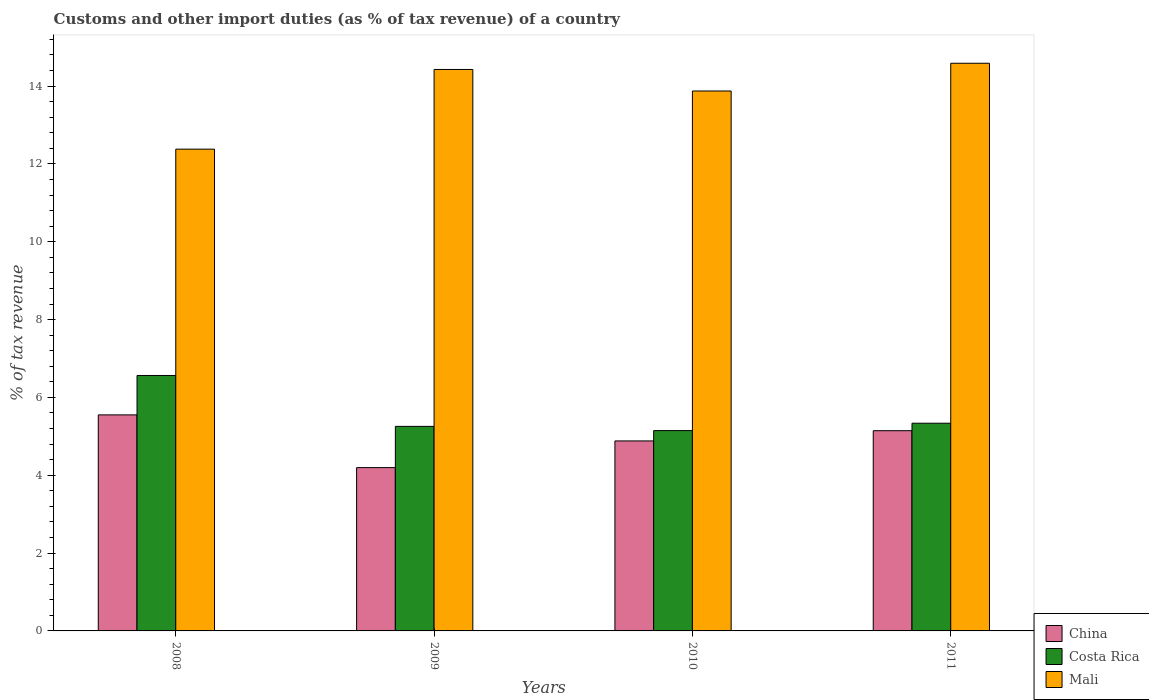How many different coloured bars are there?
Provide a short and direct response. 3. Are the number of bars per tick equal to the number of legend labels?
Offer a very short reply. Yes. Are the number of bars on each tick of the X-axis equal?
Your answer should be very brief. Yes. How many bars are there on the 4th tick from the right?
Give a very brief answer. 3. In how many cases, is the number of bars for a given year not equal to the number of legend labels?
Offer a terse response. 0. What is the percentage of tax revenue from customs in Costa Rica in 2009?
Your response must be concise. 5.26. Across all years, what is the maximum percentage of tax revenue from customs in Mali?
Provide a succinct answer. 14.59. Across all years, what is the minimum percentage of tax revenue from customs in China?
Make the answer very short. 4.2. In which year was the percentage of tax revenue from customs in Mali maximum?
Ensure brevity in your answer.  2011. What is the total percentage of tax revenue from customs in Mali in the graph?
Provide a succinct answer. 55.26. What is the difference between the percentage of tax revenue from customs in China in 2008 and that in 2009?
Provide a succinct answer. 1.36. What is the difference between the percentage of tax revenue from customs in Costa Rica in 2011 and the percentage of tax revenue from customs in Mali in 2009?
Provide a short and direct response. -9.09. What is the average percentage of tax revenue from customs in Mali per year?
Make the answer very short. 13.82. In the year 2008, what is the difference between the percentage of tax revenue from customs in Costa Rica and percentage of tax revenue from customs in China?
Make the answer very short. 1.01. In how many years, is the percentage of tax revenue from customs in Costa Rica greater than 8.4 %?
Keep it short and to the point. 0. What is the ratio of the percentage of tax revenue from customs in Mali in 2010 to that in 2011?
Provide a short and direct response. 0.95. Is the percentage of tax revenue from customs in China in 2009 less than that in 2011?
Offer a terse response. Yes. What is the difference between the highest and the second highest percentage of tax revenue from customs in Costa Rica?
Keep it short and to the point. 1.23. What is the difference between the highest and the lowest percentage of tax revenue from customs in China?
Ensure brevity in your answer.  1.36. In how many years, is the percentage of tax revenue from customs in Mali greater than the average percentage of tax revenue from customs in Mali taken over all years?
Make the answer very short. 3. Is the sum of the percentage of tax revenue from customs in Costa Rica in 2008 and 2010 greater than the maximum percentage of tax revenue from customs in Mali across all years?
Your answer should be very brief. No. What does the 3rd bar from the left in 2011 represents?
Provide a short and direct response. Mali. What does the 1st bar from the right in 2009 represents?
Offer a terse response. Mali. Is it the case that in every year, the sum of the percentage of tax revenue from customs in Mali and percentage of tax revenue from customs in Costa Rica is greater than the percentage of tax revenue from customs in China?
Offer a very short reply. Yes. Are all the bars in the graph horizontal?
Ensure brevity in your answer.  No. How many years are there in the graph?
Your answer should be very brief. 4. How are the legend labels stacked?
Your response must be concise. Vertical. What is the title of the graph?
Give a very brief answer. Customs and other import duties (as % of tax revenue) of a country. Does "United Arab Emirates" appear as one of the legend labels in the graph?
Make the answer very short. No. What is the label or title of the X-axis?
Give a very brief answer. Years. What is the label or title of the Y-axis?
Ensure brevity in your answer.  % of tax revenue. What is the % of tax revenue in China in 2008?
Your answer should be compact. 5.55. What is the % of tax revenue of Costa Rica in 2008?
Your answer should be very brief. 6.56. What is the % of tax revenue in Mali in 2008?
Offer a terse response. 12.38. What is the % of tax revenue in China in 2009?
Make the answer very short. 4.2. What is the % of tax revenue in Costa Rica in 2009?
Your answer should be compact. 5.26. What is the % of tax revenue of Mali in 2009?
Offer a very short reply. 14.43. What is the % of tax revenue of China in 2010?
Keep it short and to the point. 4.88. What is the % of tax revenue of Costa Rica in 2010?
Offer a very short reply. 5.15. What is the % of tax revenue in Mali in 2010?
Your answer should be compact. 13.87. What is the % of tax revenue in China in 2011?
Ensure brevity in your answer.  5.14. What is the % of tax revenue of Costa Rica in 2011?
Your response must be concise. 5.34. What is the % of tax revenue of Mali in 2011?
Offer a very short reply. 14.59. Across all years, what is the maximum % of tax revenue in China?
Provide a succinct answer. 5.55. Across all years, what is the maximum % of tax revenue of Costa Rica?
Offer a terse response. 6.56. Across all years, what is the maximum % of tax revenue in Mali?
Ensure brevity in your answer.  14.59. Across all years, what is the minimum % of tax revenue in China?
Your answer should be compact. 4.2. Across all years, what is the minimum % of tax revenue in Costa Rica?
Make the answer very short. 5.15. Across all years, what is the minimum % of tax revenue of Mali?
Provide a short and direct response. 12.38. What is the total % of tax revenue of China in the graph?
Make the answer very short. 19.77. What is the total % of tax revenue of Costa Rica in the graph?
Give a very brief answer. 22.3. What is the total % of tax revenue in Mali in the graph?
Give a very brief answer. 55.26. What is the difference between the % of tax revenue of China in 2008 and that in 2009?
Your response must be concise. 1.36. What is the difference between the % of tax revenue in Costa Rica in 2008 and that in 2009?
Make the answer very short. 1.31. What is the difference between the % of tax revenue of Mali in 2008 and that in 2009?
Provide a succinct answer. -2.05. What is the difference between the % of tax revenue of China in 2008 and that in 2010?
Offer a very short reply. 0.67. What is the difference between the % of tax revenue of Costa Rica in 2008 and that in 2010?
Ensure brevity in your answer.  1.42. What is the difference between the % of tax revenue of Mali in 2008 and that in 2010?
Ensure brevity in your answer.  -1.49. What is the difference between the % of tax revenue of China in 2008 and that in 2011?
Give a very brief answer. 0.41. What is the difference between the % of tax revenue of Costa Rica in 2008 and that in 2011?
Your answer should be very brief. 1.23. What is the difference between the % of tax revenue in Mali in 2008 and that in 2011?
Your answer should be compact. -2.21. What is the difference between the % of tax revenue of China in 2009 and that in 2010?
Ensure brevity in your answer.  -0.69. What is the difference between the % of tax revenue in Costa Rica in 2009 and that in 2010?
Provide a succinct answer. 0.11. What is the difference between the % of tax revenue of Mali in 2009 and that in 2010?
Your answer should be very brief. 0.55. What is the difference between the % of tax revenue of China in 2009 and that in 2011?
Your response must be concise. -0.95. What is the difference between the % of tax revenue in Costa Rica in 2009 and that in 2011?
Offer a very short reply. -0.08. What is the difference between the % of tax revenue of Mali in 2009 and that in 2011?
Provide a short and direct response. -0.16. What is the difference between the % of tax revenue in China in 2010 and that in 2011?
Your answer should be compact. -0.26. What is the difference between the % of tax revenue in Costa Rica in 2010 and that in 2011?
Your response must be concise. -0.19. What is the difference between the % of tax revenue of Mali in 2010 and that in 2011?
Make the answer very short. -0.71. What is the difference between the % of tax revenue in China in 2008 and the % of tax revenue in Costa Rica in 2009?
Ensure brevity in your answer.  0.3. What is the difference between the % of tax revenue in China in 2008 and the % of tax revenue in Mali in 2009?
Make the answer very short. -8.88. What is the difference between the % of tax revenue of Costa Rica in 2008 and the % of tax revenue of Mali in 2009?
Make the answer very short. -7.86. What is the difference between the % of tax revenue in China in 2008 and the % of tax revenue in Costa Rica in 2010?
Keep it short and to the point. 0.4. What is the difference between the % of tax revenue in China in 2008 and the % of tax revenue in Mali in 2010?
Offer a terse response. -8.32. What is the difference between the % of tax revenue of Costa Rica in 2008 and the % of tax revenue of Mali in 2010?
Provide a short and direct response. -7.31. What is the difference between the % of tax revenue in China in 2008 and the % of tax revenue in Costa Rica in 2011?
Provide a short and direct response. 0.21. What is the difference between the % of tax revenue of China in 2008 and the % of tax revenue of Mali in 2011?
Your answer should be compact. -9.03. What is the difference between the % of tax revenue of Costa Rica in 2008 and the % of tax revenue of Mali in 2011?
Offer a very short reply. -8.02. What is the difference between the % of tax revenue in China in 2009 and the % of tax revenue in Costa Rica in 2010?
Make the answer very short. -0.95. What is the difference between the % of tax revenue of China in 2009 and the % of tax revenue of Mali in 2010?
Make the answer very short. -9.68. What is the difference between the % of tax revenue of Costa Rica in 2009 and the % of tax revenue of Mali in 2010?
Give a very brief answer. -8.62. What is the difference between the % of tax revenue in China in 2009 and the % of tax revenue in Costa Rica in 2011?
Your answer should be very brief. -1.14. What is the difference between the % of tax revenue of China in 2009 and the % of tax revenue of Mali in 2011?
Give a very brief answer. -10.39. What is the difference between the % of tax revenue of Costa Rica in 2009 and the % of tax revenue of Mali in 2011?
Offer a very short reply. -9.33. What is the difference between the % of tax revenue in China in 2010 and the % of tax revenue in Costa Rica in 2011?
Your response must be concise. -0.45. What is the difference between the % of tax revenue in China in 2010 and the % of tax revenue in Mali in 2011?
Make the answer very short. -9.7. What is the difference between the % of tax revenue in Costa Rica in 2010 and the % of tax revenue in Mali in 2011?
Give a very brief answer. -9.44. What is the average % of tax revenue in China per year?
Offer a very short reply. 4.94. What is the average % of tax revenue of Costa Rica per year?
Give a very brief answer. 5.58. What is the average % of tax revenue in Mali per year?
Your answer should be very brief. 13.82. In the year 2008, what is the difference between the % of tax revenue in China and % of tax revenue in Costa Rica?
Make the answer very short. -1.01. In the year 2008, what is the difference between the % of tax revenue of China and % of tax revenue of Mali?
Provide a succinct answer. -6.83. In the year 2008, what is the difference between the % of tax revenue of Costa Rica and % of tax revenue of Mali?
Your answer should be very brief. -5.82. In the year 2009, what is the difference between the % of tax revenue in China and % of tax revenue in Costa Rica?
Keep it short and to the point. -1.06. In the year 2009, what is the difference between the % of tax revenue of China and % of tax revenue of Mali?
Your answer should be very brief. -10.23. In the year 2009, what is the difference between the % of tax revenue in Costa Rica and % of tax revenue in Mali?
Ensure brevity in your answer.  -9.17. In the year 2010, what is the difference between the % of tax revenue in China and % of tax revenue in Costa Rica?
Your response must be concise. -0.27. In the year 2010, what is the difference between the % of tax revenue in China and % of tax revenue in Mali?
Keep it short and to the point. -8.99. In the year 2010, what is the difference between the % of tax revenue of Costa Rica and % of tax revenue of Mali?
Ensure brevity in your answer.  -8.73. In the year 2011, what is the difference between the % of tax revenue in China and % of tax revenue in Costa Rica?
Give a very brief answer. -0.19. In the year 2011, what is the difference between the % of tax revenue of China and % of tax revenue of Mali?
Give a very brief answer. -9.44. In the year 2011, what is the difference between the % of tax revenue of Costa Rica and % of tax revenue of Mali?
Keep it short and to the point. -9.25. What is the ratio of the % of tax revenue in China in 2008 to that in 2009?
Your answer should be very brief. 1.32. What is the ratio of the % of tax revenue of Costa Rica in 2008 to that in 2009?
Your response must be concise. 1.25. What is the ratio of the % of tax revenue in Mali in 2008 to that in 2009?
Offer a terse response. 0.86. What is the ratio of the % of tax revenue in China in 2008 to that in 2010?
Ensure brevity in your answer.  1.14. What is the ratio of the % of tax revenue of Costa Rica in 2008 to that in 2010?
Your answer should be compact. 1.28. What is the ratio of the % of tax revenue in Mali in 2008 to that in 2010?
Offer a very short reply. 0.89. What is the ratio of the % of tax revenue of China in 2008 to that in 2011?
Keep it short and to the point. 1.08. What is the ratio of the % of tax revenue of Costa Rica in 2008 to that in 2011?
Offer a very short reply. 1.23. What is the ratio of the % of tax revenue in Mali in 2008 to that in 2011?
Your response must be concise. 0.85. What is the ratio of the % of tax revenue of China in 2009 to that in 2010?
Keep it short and to the point. 0.86. What is the ratio of the % of tax revenue in Costa Rica in 2009 to that in 2010?
Your answer should be very brief. 1.02. What is the ratio of the % of tax revenue of Mali in 2009 to that in 2010?
Keep it short and to the point. 1.04. What is the ratio of the % of tax revenue of China in 2009 to that in 2011?
Keep it short and to the point. 0.82. What is the ratio of the % of tax revenue of Mali in 2009 to that in 2011?
Your answer should be compact. 0.99. What is the ratio of the % of tax revenue of China in 2010 to that in 2011?
Your answer should be very brief. 0.95. What is the ratio of the % of tax revenue of Costa Rica in 2010 to that in 2011?
Ensure brevity in your answer.  0.96. What is the ratio of the % of tax revenue of Mali in 2010 to that in 2011?
Give a very brief answer. 0.95. What is the difference between the highest and the second highest % of tax revenue in China?
Give a very brief answer. 0.41. What is the difference between the highest and the second highest % of tax revenue of Costa Rica?
Offer a terse response. 1.23. What is the difference between the highest and the second highest % of tax revenue in Mali?
Give a very brief answer. 0.16. What is the difference between the highest and the lowest % of tax revenue in China?
Ensure brevity in your answer.  1.36. What is the difference between the highest and the lowest % of tax revenue in Costa Rica?
Keep it short and to the point. 1.42. What is the difference between the highest and the lowest % of tax revenue of Mali?
Keep it short and to the point. 2.21. 